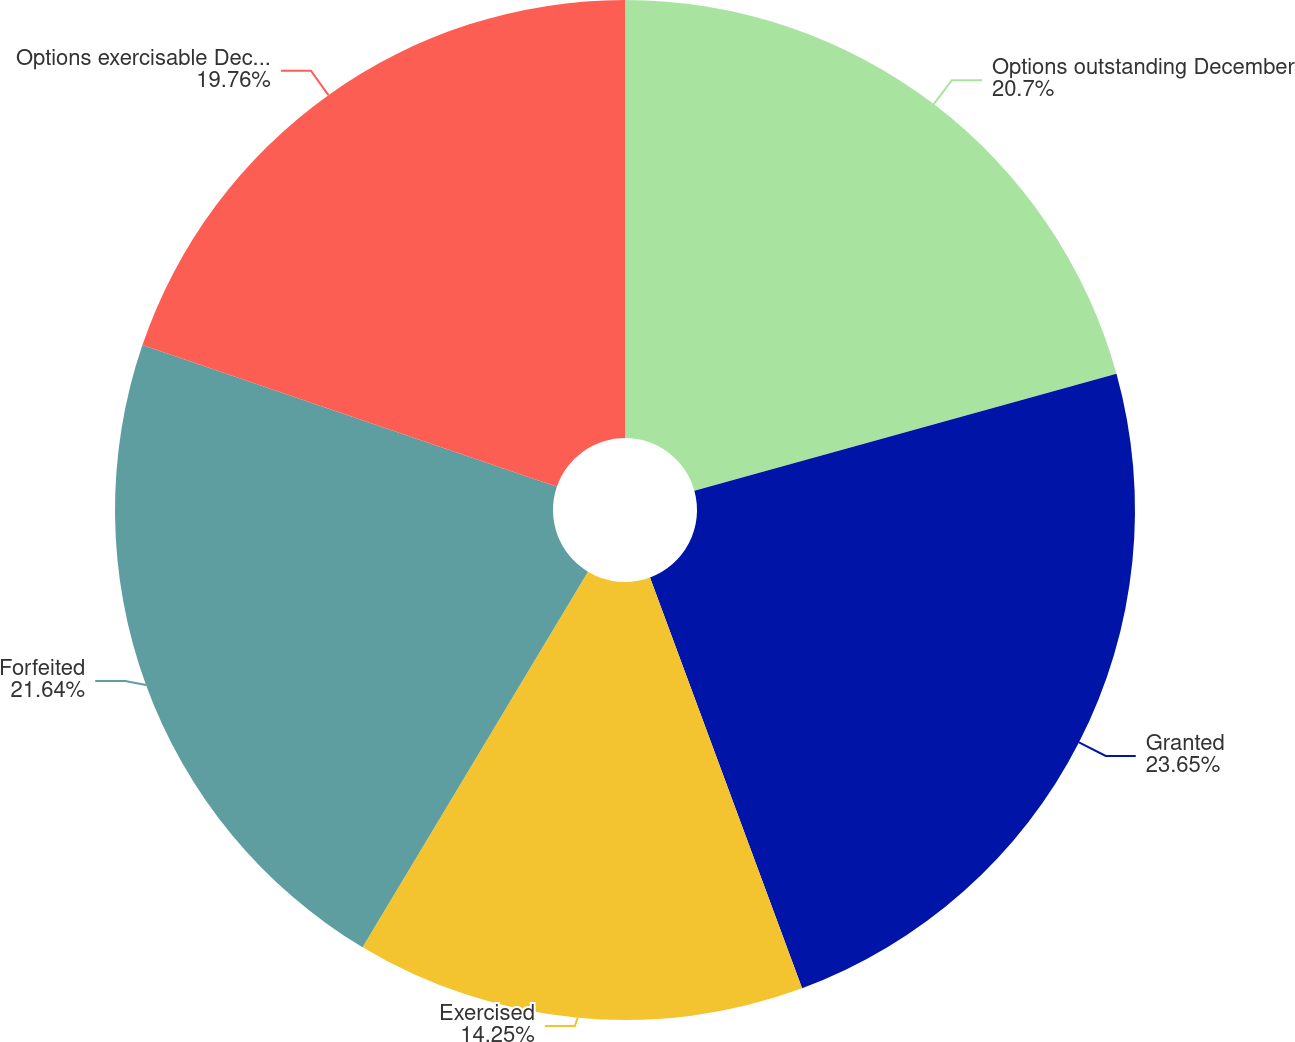Convert chart to OTSL. <chart><loc_0><loc_0><loc_500><loc_500><pie_chart><fcel>Options outstanding December<fcel>Granted<fcel>Exercised<fcel>Forfeited<fcel>Options exercisable December<nl><fcel>20.7%<fcel>23.66%<fcel>14.25%<fcel>21.64%<fcel>19.76%<nl></chart> 